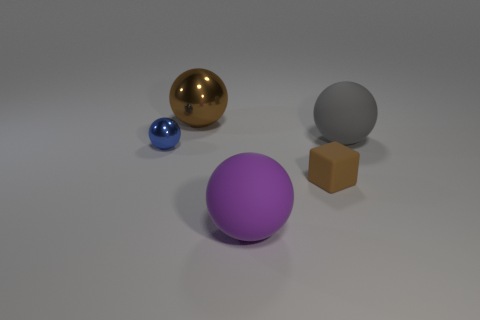How many small matte objects are behind the large purple sphere?
Keep it short and to the point. 1. Are the small brown block and the purple ball made of the same material?
Make the answer very short. Yes. How many things are both in front of the gray matte object and to the right of the brown metal object?
Your answer should be very brief. 2. What number of other objects are the same color as the tiny matte thing?
Keep it short and to the point. 1. What number of green things are either small metal spheres or large balls?
Keep it short and to the point. 0. The brown sphere is what size?
Make the answer very short. Large. What number of shiny objects are large purple things or cubes?
Make the answer very short. 0. Are there fewer small blue balls than brown metallic cylinders?
Give a very brief answer. No. What number of other objects are the same material as the small blue thing?
Give a very brief answer. 1. What is the size of the blue thing that is the same shape as the purple rubber thing?
Your answer should be very brief. Small. 